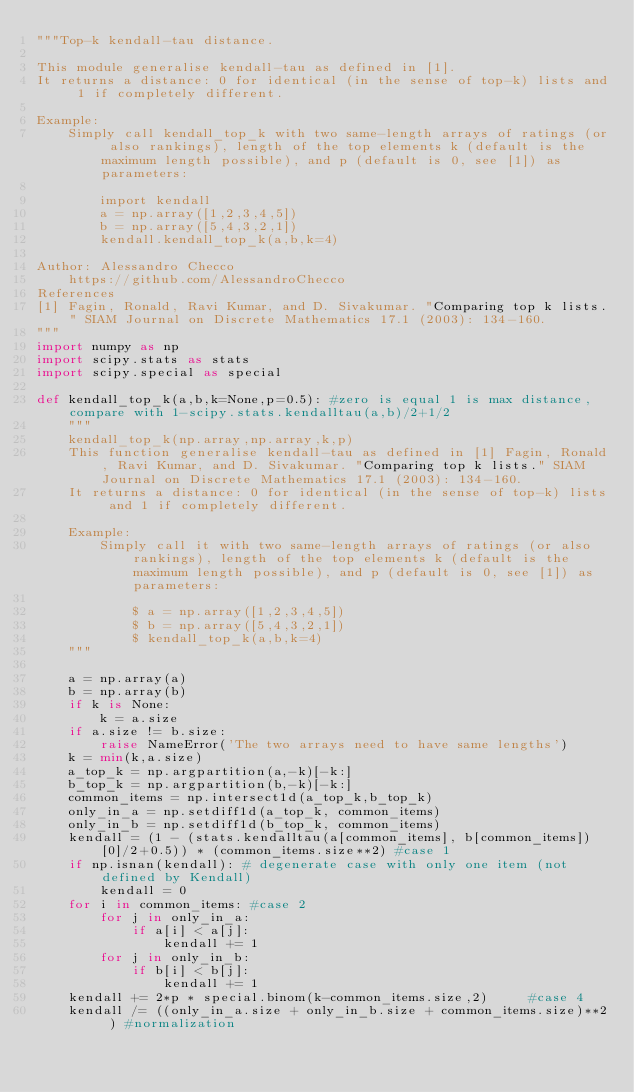<code> <loc_0><loc_0><loc_500><loc_500><_Python_>"""Top-k kendall-tau distance.

This module generalise kendall-tau as defined in [1].
It returns a distance: 0 for identical (in the sense of top-k) lists and 1 if completely different.

Example:
    Simply call kendall_top_k with two same-length arrays of ratings (or also rankings), length of the top elements k (default is the maximum length possible), and p (default is 0, see [1]) as parameters:

        import kendall
        a = np.array([1,2,3,4,5])
        b = np.array([5,4,3,2,1])
        kendall.kendall_top_k(a,b,k=4)

Author: Alessandro Checco
    https://github.com/AlessandroChecco
References
[1] Fagin, Ronald, Ravi Kumar, and D. Sivakumar. "Comparing top k lists." SIAM Journal on Discrete Mathematics 17.1 (2003): 134-160.
"""
import numpy as np
import scipy.stats as stats
import scipy.special as special

def kendall_top_k(a,b,k=None,p=0.5): #zero is equal 1 is max distance, compare with 1-scipy.stats.kendalltau(a,b)/2+1/2
    """
    kendall_top_k(np.array,np.array,k,p)
    This function generalise kendall-tau as defined in [1] Fagin, Ronald, Ravi Kumar, and D. Sivakumar. "Comparing top k lists." SIAM Journal on Discrete Mathematics 17.1 (2003): 134-160.
    It returns a distance: 0 for identical (in the sense of top-k) lists and 1 if completely different.

    Example:
        Simply call it with two same-length arrays of ratings (or also rankings), length of the top elements k (default is the maximum length possible), and p (default is 0, see [1]) as parameters:

            $ a = np.array([1,2,3,4,5])
            $ b = np.array([5,4,3,2,1])
            $ kendall_top_k(a,b,k=4)
    """

    a = np.array(a)
    b = np.array(b)
    if k is None:
        k = a.size
    if a.size != b.size:
        raise NameError('The two arrays need to have same lengths')
    k = min(k,a.size)
    a_top_k = np.argpartition(a,-k)[-k:]
    b_top_k = np.argpartition(b,-k)[-k:]
    common_items = np.intersect1d(a_top_k,b_top_k)
    only_in_a = np.setdiff1d(a_top_k, common_items)
    only_in_b = np.setdiff1d(b_top_k, common_items)
    kendall = (1 - (stats.kendalltau(a[common_items], b[common_items])[0]/2+0.5)) * (common_items.size**2) #case 1
    if np.isnan(kendall): # degenerate case with only one item (not defined by Kendall)
        kendall = 0
    for i in common_items: #case 2
        for j in only_in_a:
            if a[i] < a[j]:
                kendall += 1
        for j in only_in_b:
            if b[i] < b[j]:
                kendall += 1
    kendall += 2*p * special.binom(k-common_items.size,2)     #case 4
    kendall /= ((only_in_a.size + only_in_b.size + common_items.size)**2 ) #normalization</code> 